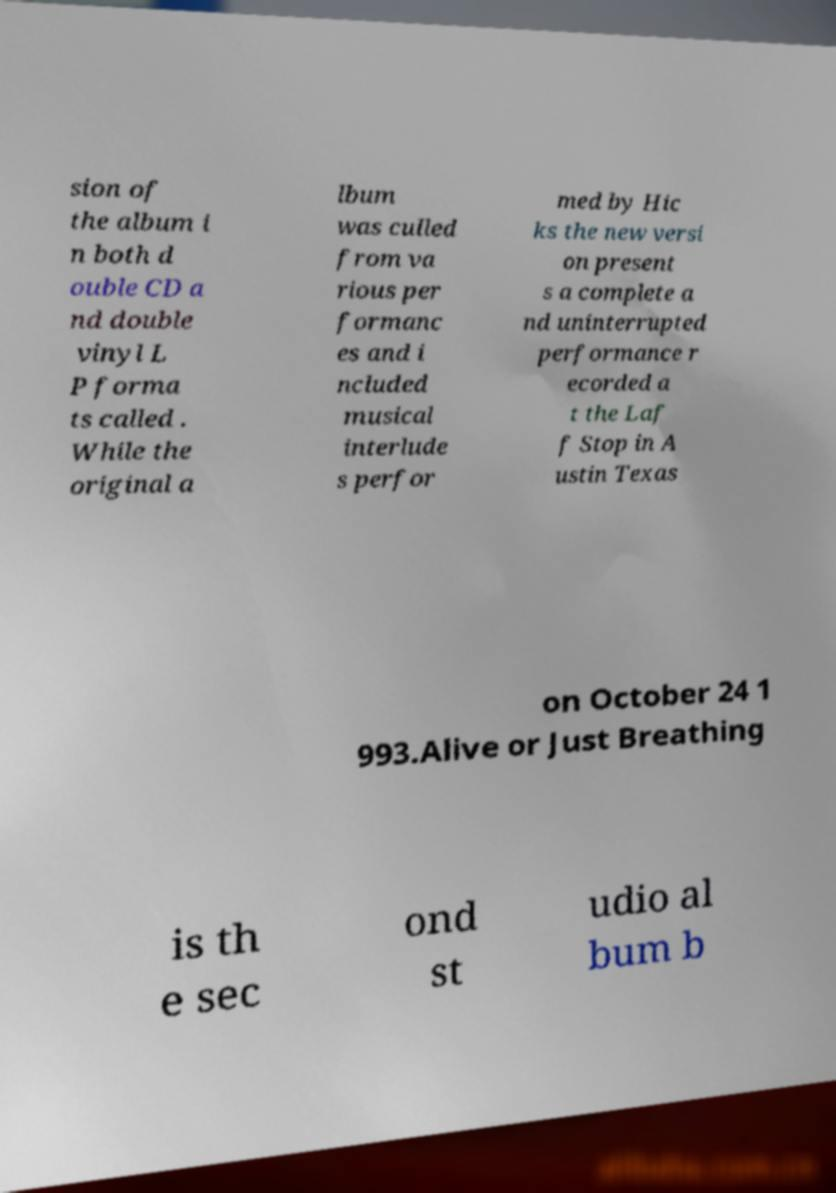For documentation purposes, I need the text within this image transcribed. Could you provide that? sion of the album i n both d ouble CD a nd double vinyl L P forma ts called . While the original a lbum was culled from va rious per formanc es and i ncluded musical interlude s perfor med by Hic ks the new versi on present s a complete a nd uninterrupted performance r ecorded a t the Laf f Stop in A ustin Texas on October 24 1 993.Alive or Just Breathing is th e sec ond st udio al bum b 